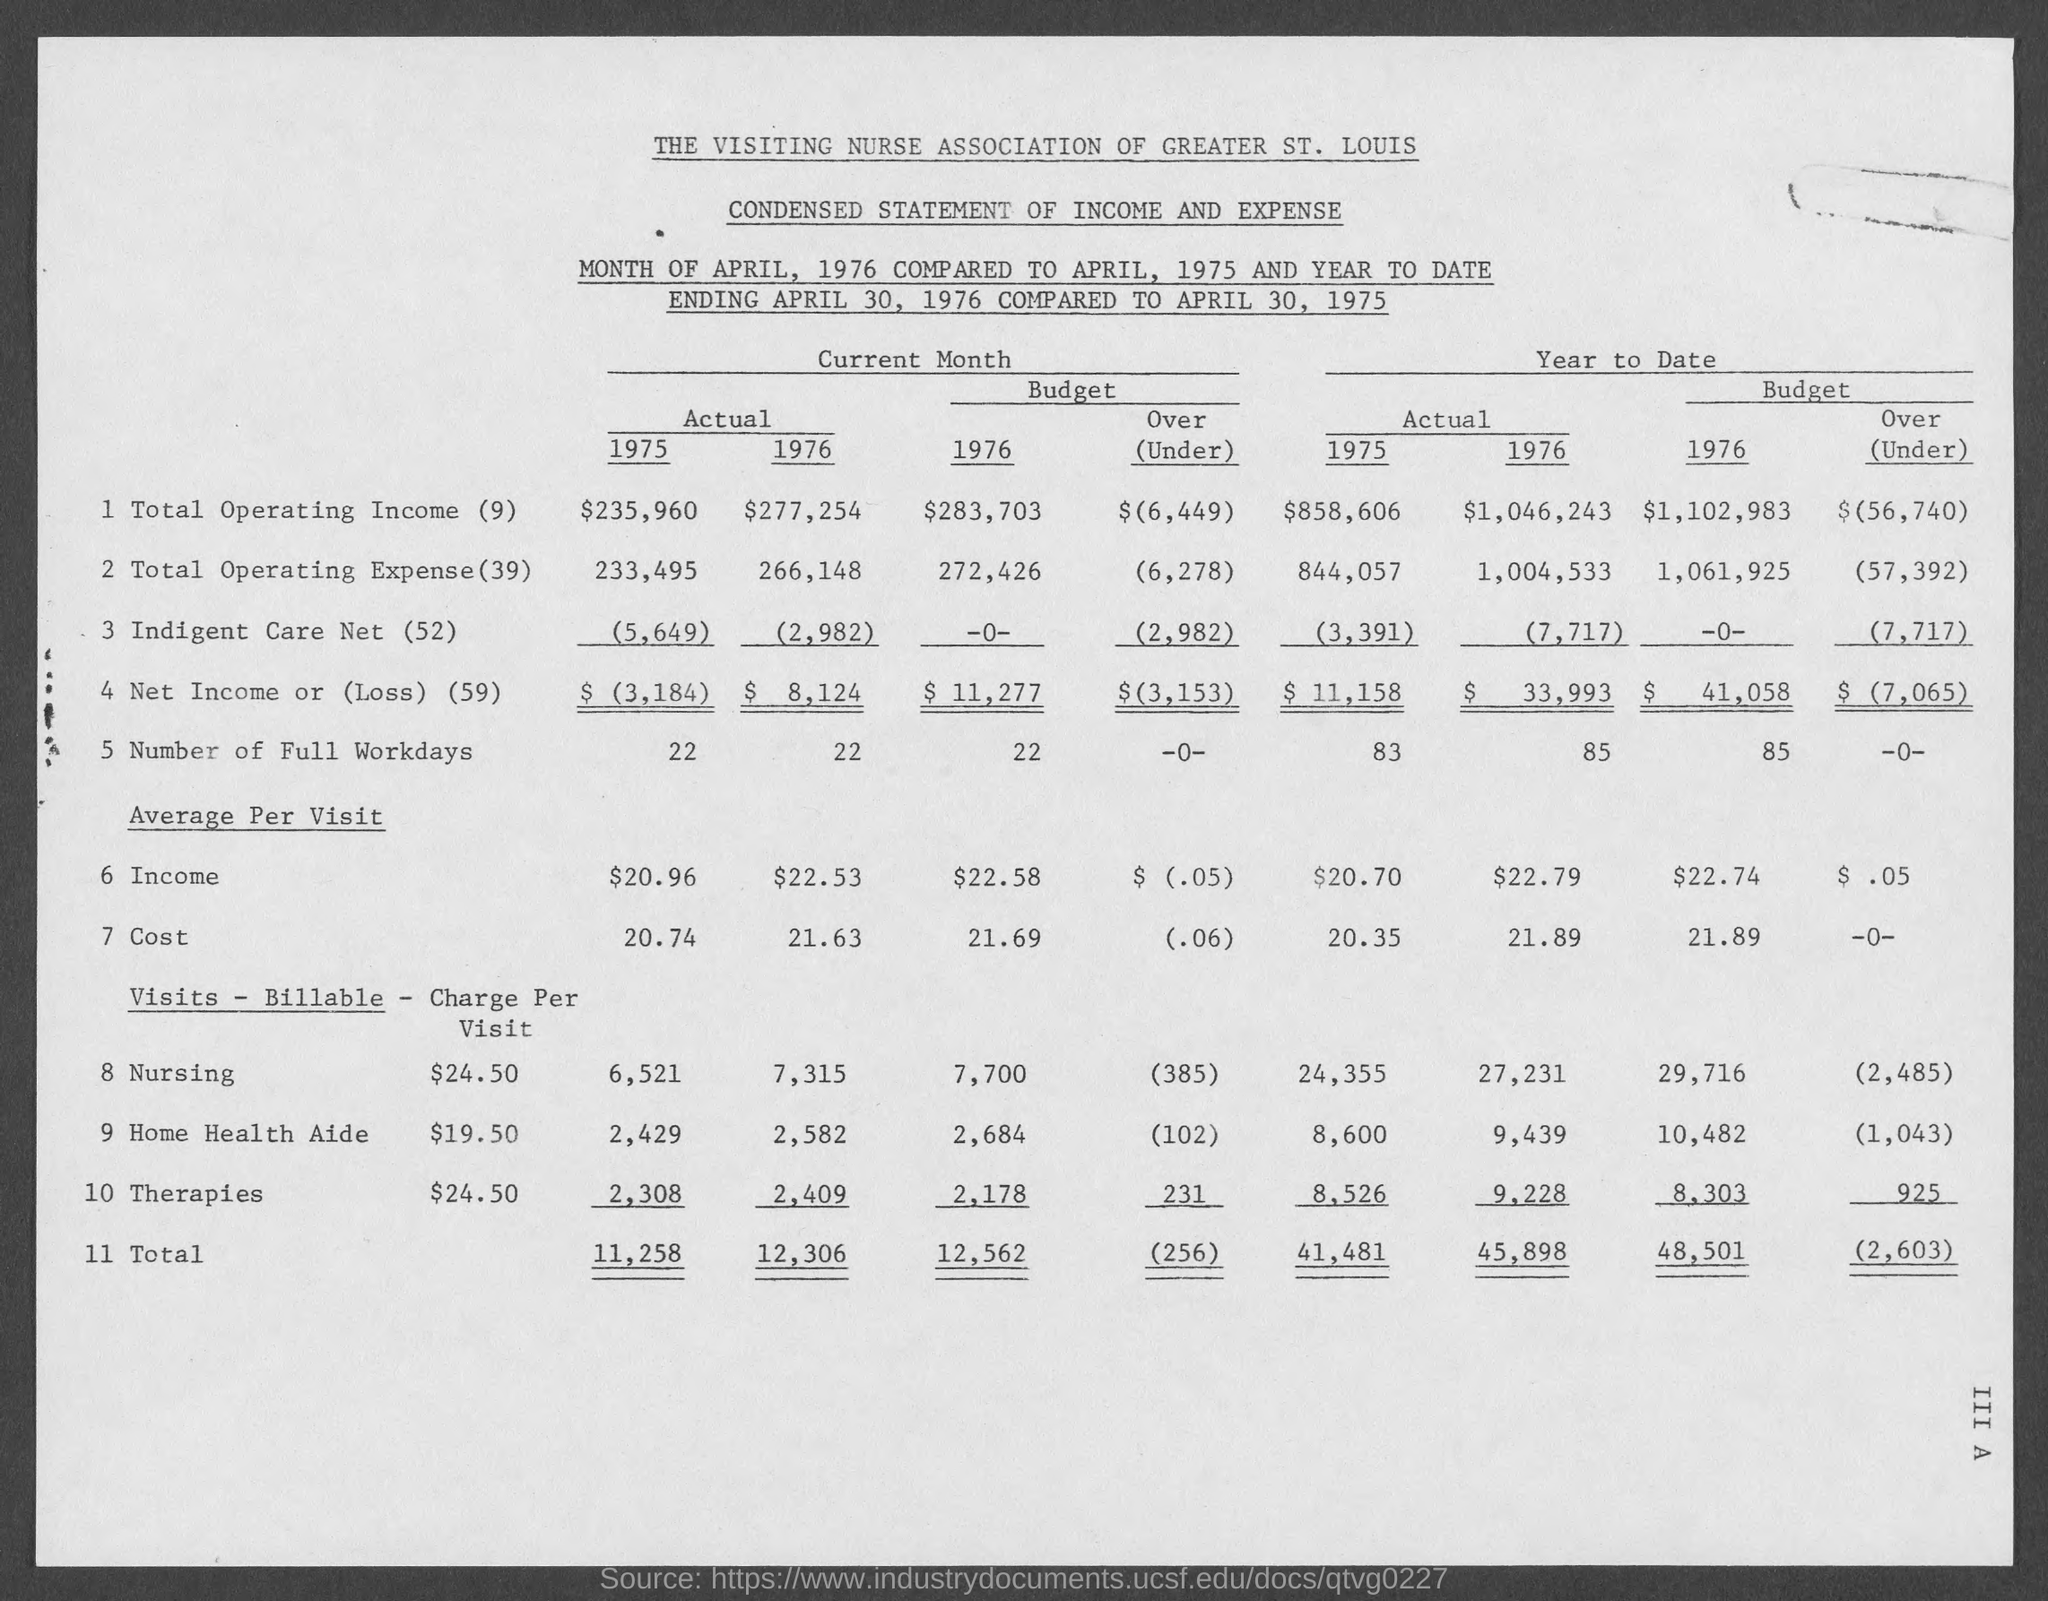Give some essential details in this illustration. The actual total for 1975 for the current month is 11,258. What is the actual number of full workdays for the current month in 1976? The actual total operating expense for the current month of 1976 is 266,148. The request is to determine the number of full workdays for the current month of 1976. The actual total operating income for the current month of 1975 is $235,960. 